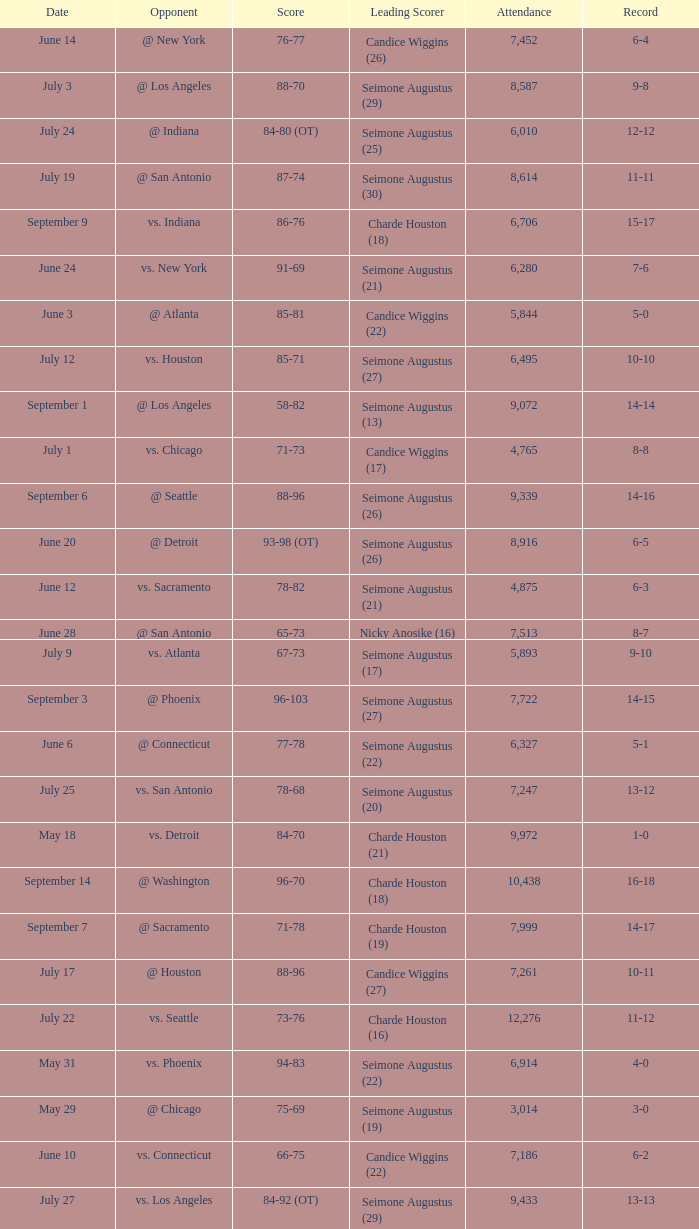Which Score has an Opponent of @ houston, and a Record of 2-0? 98-92 (OT). 